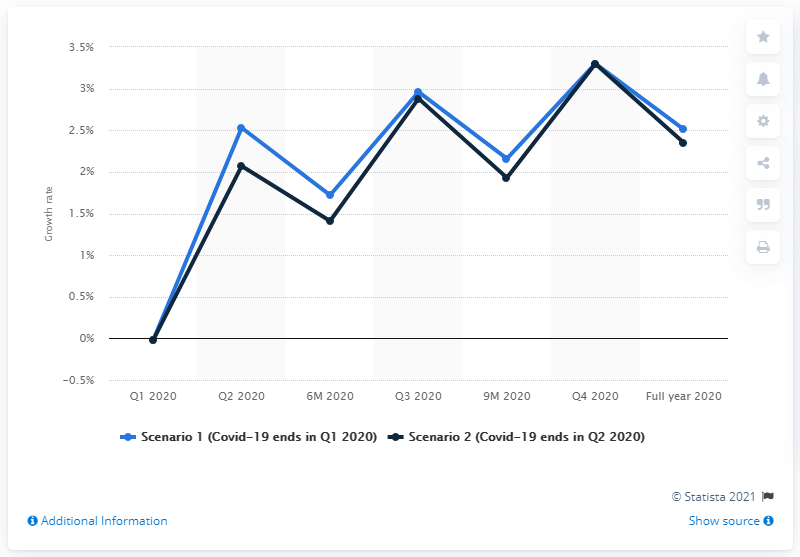Mention a couple of crucial points in this snapshot. According to projections, the agriculture sector was expected to increase by 2.35% in the second quarter of 2020. 